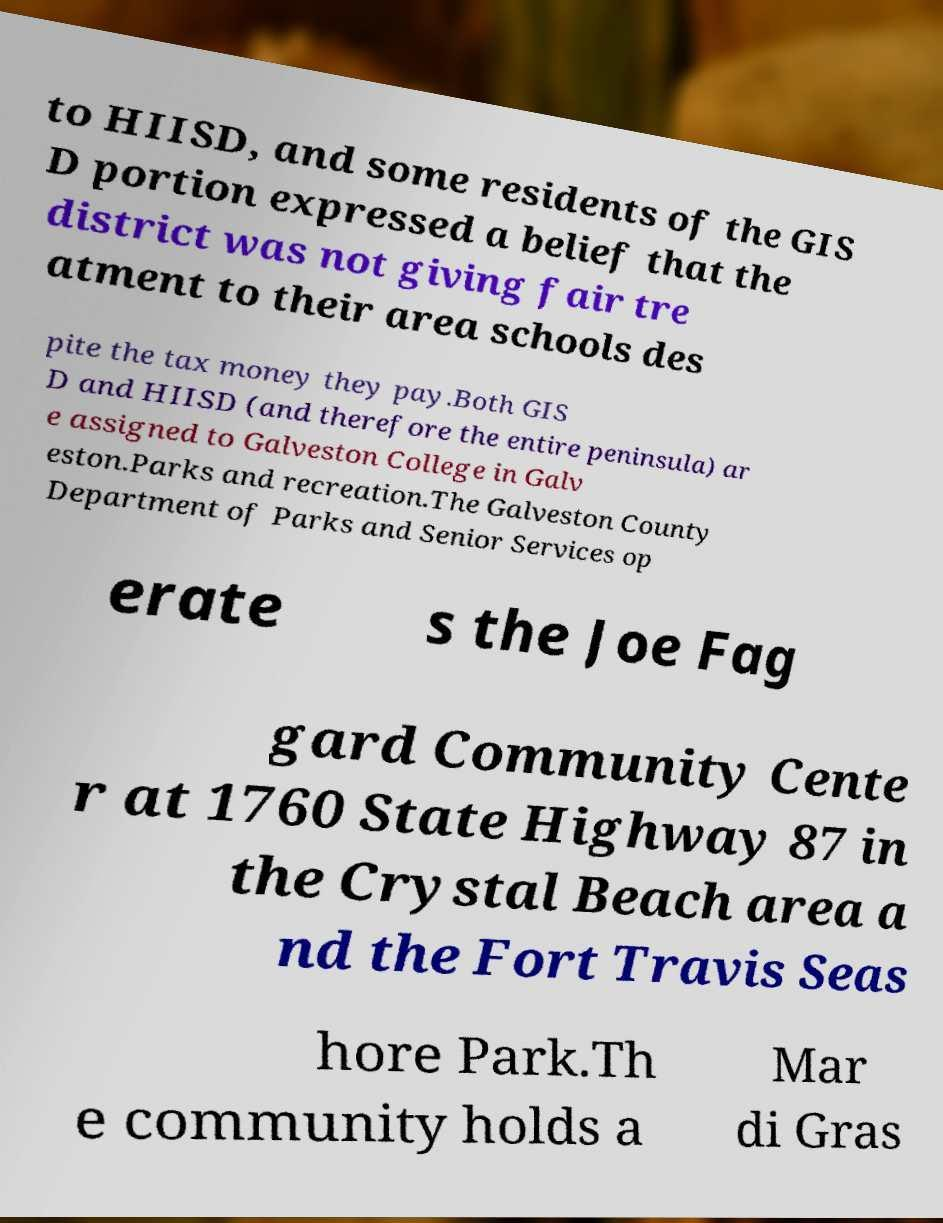I need the written content from this picture converted into text. Can you do that? to HIISD, and some residents of the GIS D portion expressed a belief that the district was not giving fair tre atment to their area schools des pite the tax money they pay.Both GIS D and HIISD (and therefore the entire peninsula) ar e assigned to Galveston College in Galv eston.Parks and recreation.The Galveston County Department of Parks and Senior Services op erate s the Joe Fag gard Community Cente r at 1760 State Highway 87 in the Crystal Beach area a nd the Fort Travis Seas hore Park.Th e community holds a Mar di Gras 